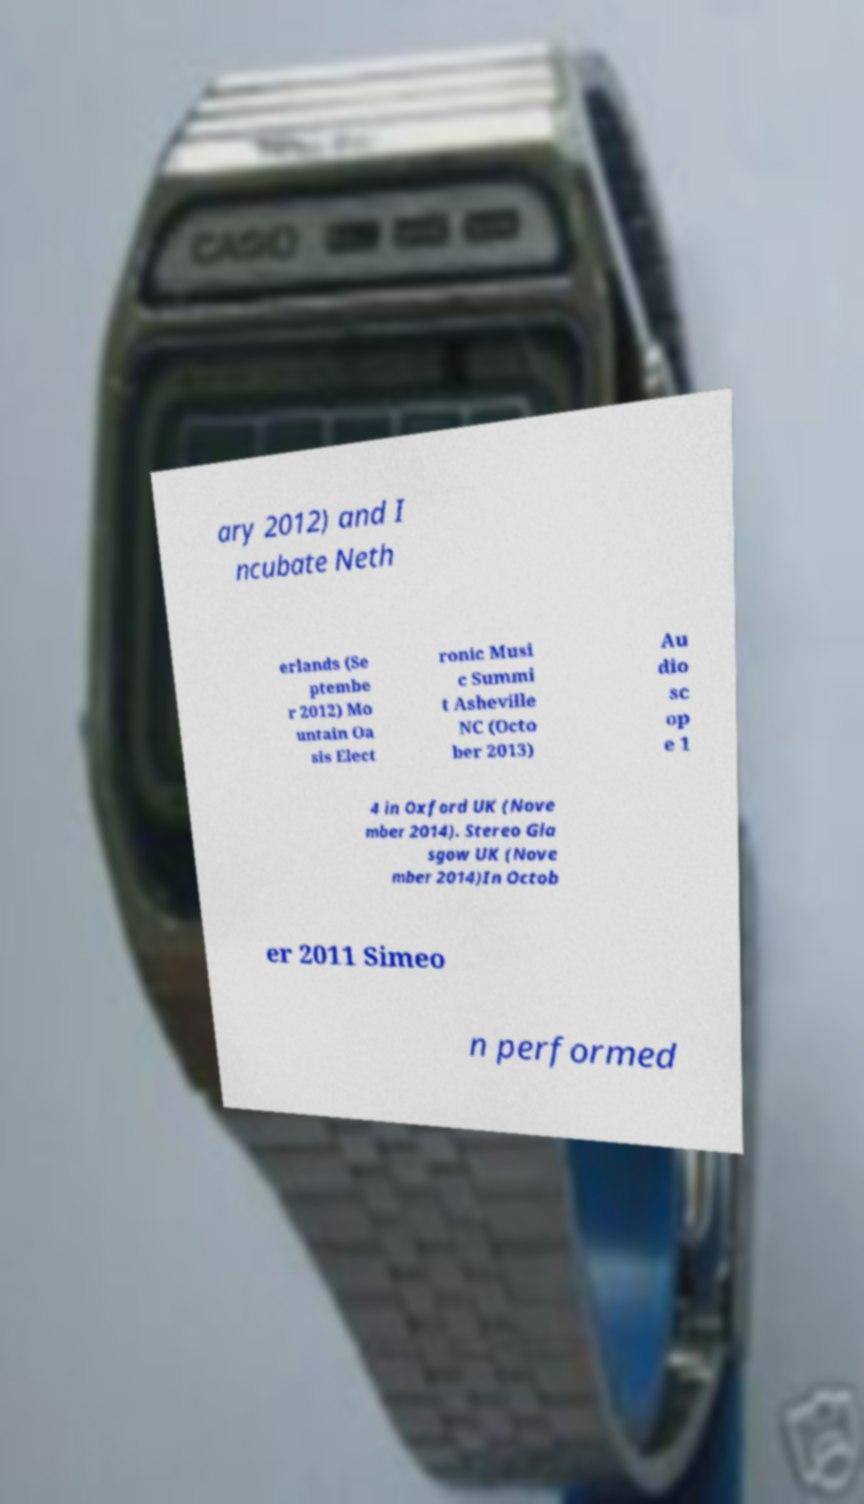Please identify and transcribe the text found in this image. ary 2012) and I ncubate Neth erlands (Se ptembe r 2012) Mo untain Oa sis Elect ronic Musi c Summi t Asheville NC (Octo ber 2013) Au dio sc op e 1 4 in Oxford UK (Nove mber 2014). Stereo Gla sgow UK (Nove mber 2014)In Octob er 2011 Simeo n performed 